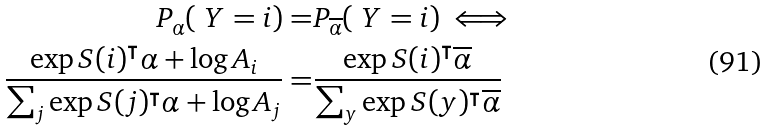Convert formula to latex. <formula><loc_0><loc_0><loc_500><loc_500>P _ { \alpha } ( \ Y = i ) = & P _ { \overline { \alpha } } ( \ Y = i ) \iff \\ \frac { \exp { S ( i ) ^ { \intercal } \alpha + \log A _ { i } } } { \sum _ { j } \exp { S ( j ) ^ { \intercal } \alpha + \log A _ { j } } } = & \frac { \exp { S ( i ) ^ { \intercal } \overline { \alpha } } } { \sum _ { y } \exp { S ( y ) ^ { \intercal } \overline { \alpha } } }</formula> 